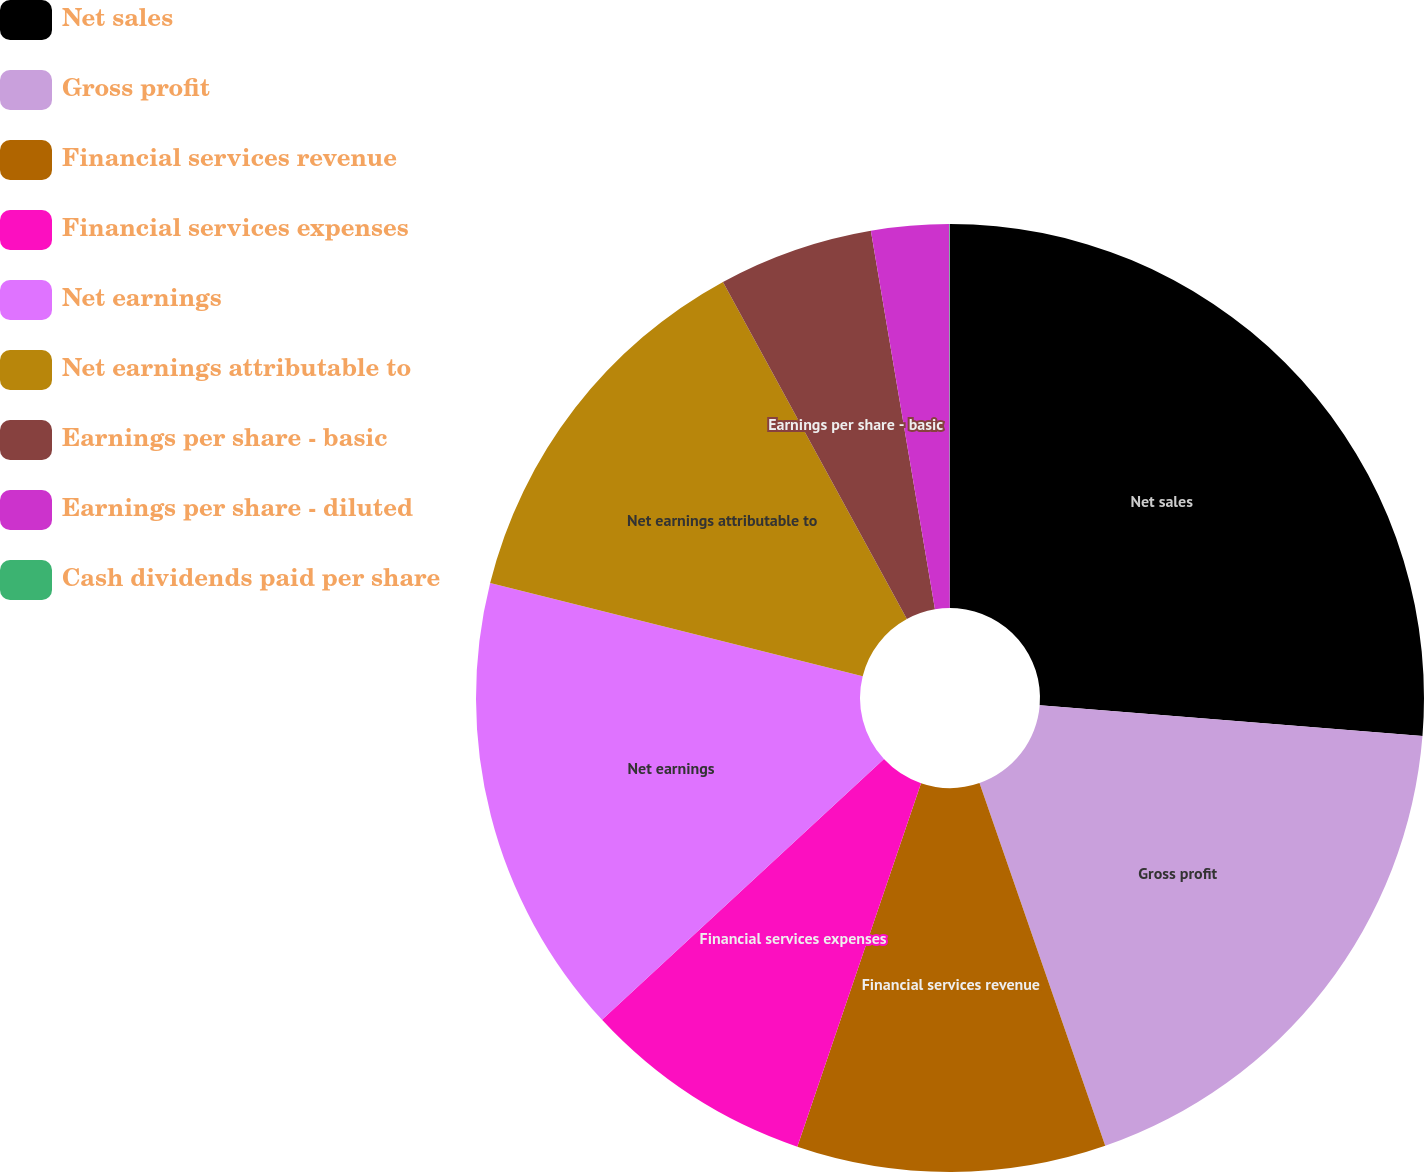Convert chart. <chart><loc_0><loc_0><loc_500><loc_500><pie_chart><fcel>Net sales<fcel>Gross profit<fcel>Financial services revenue<fcel>Financial services expenses<fcel>Net earnings<fcel>Net earnings attributable to<fcel>Earnings per share - basic<fcel>Earnings per share - diluted<fcel>Cash dividends paid per share<nl><fcel>26.28%<fcel>18.41%<fcel>10.53%<fcel>7.9%<fcel>15.78%<fcel>13.15%<fcel>5.28%<fcel>2.65%<fcel>0.02%<nl></chart> 